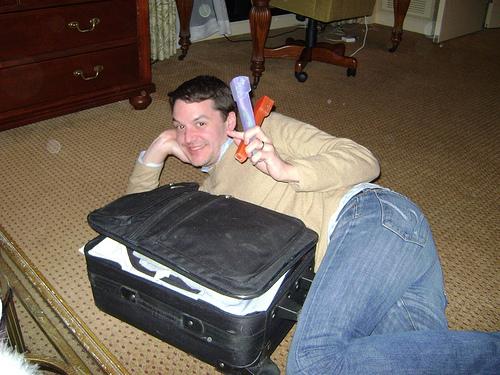What might this person be preparing for?
Keep it brief. Trip. Is this man laying on the floor or a bed?
Give a very brief answer. Floor. How many objects is the person holding?
Give a very brief answer. 2. 